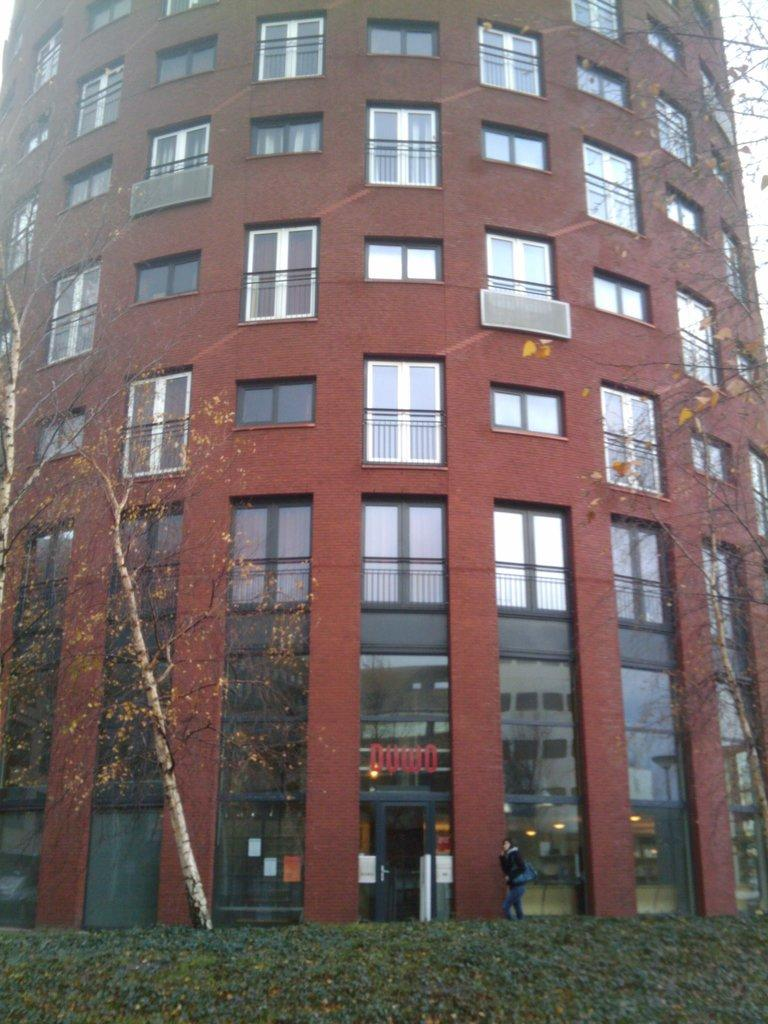What type of structure is visible in the image? There is a building in the image. What feature can be seen on the building? The building has windows. What type of vegetation is present at the bottom of the image? There are plants at the bottom of the image. Where is the tree located in the image? There is a tree on the left side of the image. What type of paper is the building made of in the image? The building is not made of paper; it is a solid structure. Does the tree have a partner in the image? There is no indication of a partner for the tree in the image. 